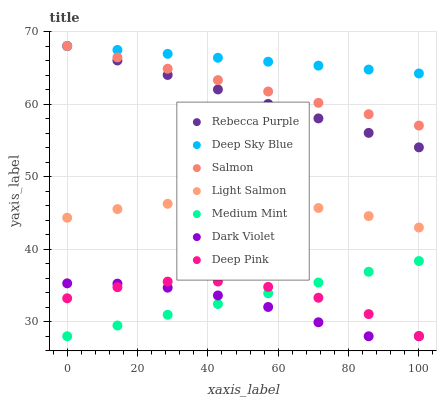Does Dark Violet have the minimum area under the curve?
Answer yes or no. Yes. Does Deep Sky Blue have the maximum area under the curve?
Answer yes or no. Yes. Does Light Salmon have the minimum area under the curve?
Answer yes or no. No. Does Light Salmon have the maximum area under the curve?
Answer yes or no. No. Is Deep Sky Blue the smoothest?
Answer yes or no. Yes. Is Deep Pink the roughest?
Answer yes or no. Yes. Is Light Salmon the smoothest?
Answer yes or no. No. Is Light Salmon the roughest?
Answer yes or no. No. Does Medium Mint have the lowest value?
Answer yes or no. Yes. Does Light Salmon have the lowest value?
Answer yes or no. No. Does Deep Sky Blue have the highest value?
Answer yes or no. Yes. Does Light Salmon have the highest value?
Answer yes or no. No. Is Deep Pink less than Deep Sky Blue?
Answer yes or no. Yes. Is Rebecca Purple greater than Deep Pink?
Answer yes or no. Yes. Does Deep Pink intersect Dark Violet?
Answer yes or no. Yes. Is Deep Pink less than Dark Violet?
Answer yes or no. No. Is Deep Pink greater than Dark Violet?
Answer yes or no. No. Does Deep Pink intersect Deep Sky Blue?
Answer yes or no. No. 